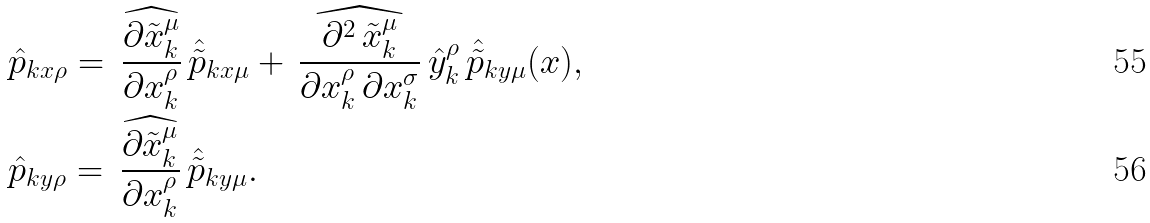Convert formula to latex. <formula><loc_0><loc_0><loc_500><loc_500>& \hat { p } _ { k x \rho } = \, \widehat { \frac { \partial \tilde { x } ^ { \mu } _ { k } } { \partial x ^ { \rho } _ { k } } } \, \hat { \tilde { p } } _ { k x \mu } + \, \widehat { \frac { \partial ^ { 2 } \, \tilde { x } ^ { \mu } _ { k } } { \partial x ^ { \rho } _ { k } \, \partial x ^ { \sigma } _ { k } } } \, \hat { y } ^ { \rho } _ { k } \, \hat { \tilde { p } } _ { k y \mu } ( x ) , \\ & \hat { p } _ { k y \rho } = \, \widehat { \frac { \partial \tilde { x } ^ { \mu } _ { k } } { \partial x ^ { \rho } _ { k } } } \, \hat { \tilde { p } } _ { k y \mu } .</formula> 